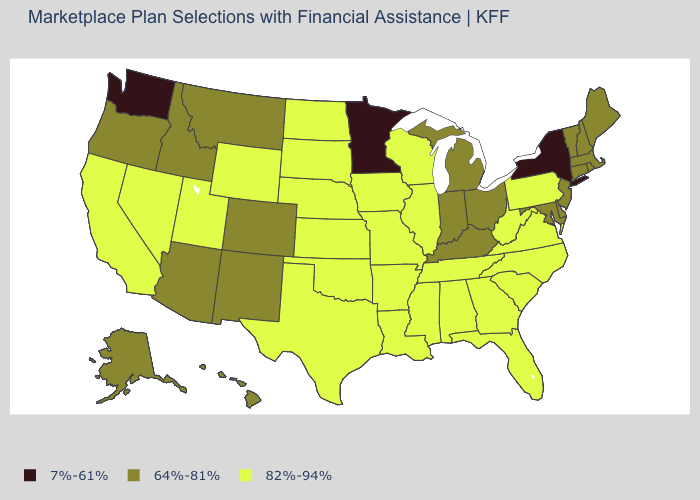Among the states that border Tennessee , which have the highest value?
Write a very short answer. Alabama, Arkansas, Georgia, Mississippi, Missouri, North Carolina, Virginia. What is the lowest value in states that border Rhode Island?
Give a very brief answer. 64%-81%. What is the value of New York?
Short answer required. 7%-61%. Which states have the highest value in the USA?
Quick response, please. Alabama, Arkansas, California, Florida, Georgia, Illinois, Iowa, Kansas, Louisiana, Mississippi, Missouri, Nebraska, Nevada, North Carolina, North Dakota, Oklahoma, Pennsylvania, South Carolina, South Dakota, Tennessee, Texas, Utah, Virginia, West Virginia, Wisconsin, Wyoming. Name the states that have a value in the range 7%-61%?
Quick response, please. Minnesota, New York, Washington. Does the map have missing data?
Answer briefly. No. Does Utah have the lowest value in the West?
Short answer required. No. Does Massachusetts have the lowest value in the Northeast?
Keep it brief. No. Does New York have the lowest value in the USA?
Write a very short answer. Yes. Does the first symbol in the legend represent the smallest category?
Keep it brief. Yes. Which states have the highest value in the USA?
Quick response, please. Alabama, Arkansas, California, Florida, Georgia, Illinois, Iowa, Kansas, Louisiana, Mississippi, Missouri, Nebraska, Nevada, North Carolina, North Dakota, Oklahoma, Pennsylvania, South Carolina, South Dakota, Tennessee, Texas, Utah, Virginia, West Virginia, Wisconsin, Wyoming. What is the value of South Dakota?
Give a very brief answer. 82%-94%. Does Missouri have the lowest value in the USA?
Give a very brief answer. No. Does Washington have the lowest value in the USA?
Write a very short answer. Yes. Name the states that have a value in the range 7%-61%?
Write a very short answer. Minnesota, New York, Washington. 